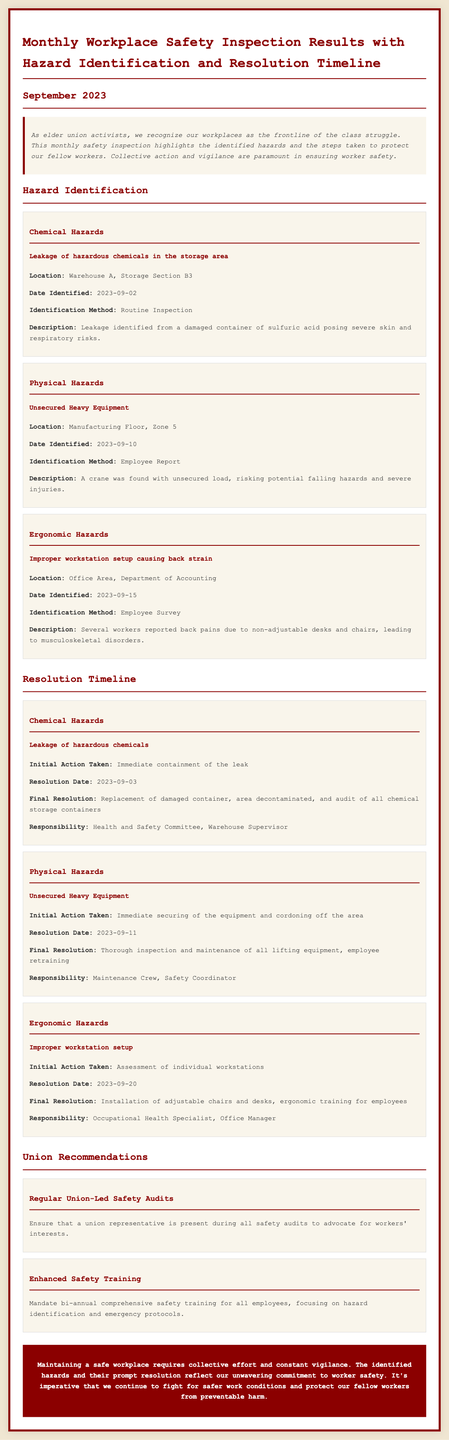what is the date the chemical hazard was identified? The chemical hazard was identified on September 2, 2023.
Answer: 2023-09-02 where was the ergonomic hazard located? The ergonomic hazard was located in the Office Area, Department of Accounting.
Answer: Office Area, Department of Accounting what action was taken for the unsecured heavy equipment? The immediate action taken was to secure the equipment and cordon off the area.
Answer: Immediate securing of the equipment and cordoning off the area who is responsible for the resolution of the chemical hazard? The responsibility for resolving the chemical hazard lies with the Health and Safety Committee and Warehouse Supervisor.
Answer: Health and Safety Committee, Warehouse Supervisor when was the final resolution for the ergonomic hazard completed? The final resolution for the ergonomic hazard was completed on September 20, 2023.
Answer: 2023-09-20 what does the report recommend regarding safety training? The report recommends mandating bi-annual comprehensive safety training for all employees.
Answer: Bi-annual comprehensive safety training what type of hazards were identified in the inspection? The hazards identified included chemical, physical, and ergonomic hazards.
Answer: Chemical, Physical, Ergonomic how many recommendations were made by the union? The union made two recommendations in the report.
Answer: Two what was the date of the resolution for the unsecured heavy equipment? The resolution for the unsecured heavy equipment was dated September 11, 2023.
Answer: 2023-09-11 